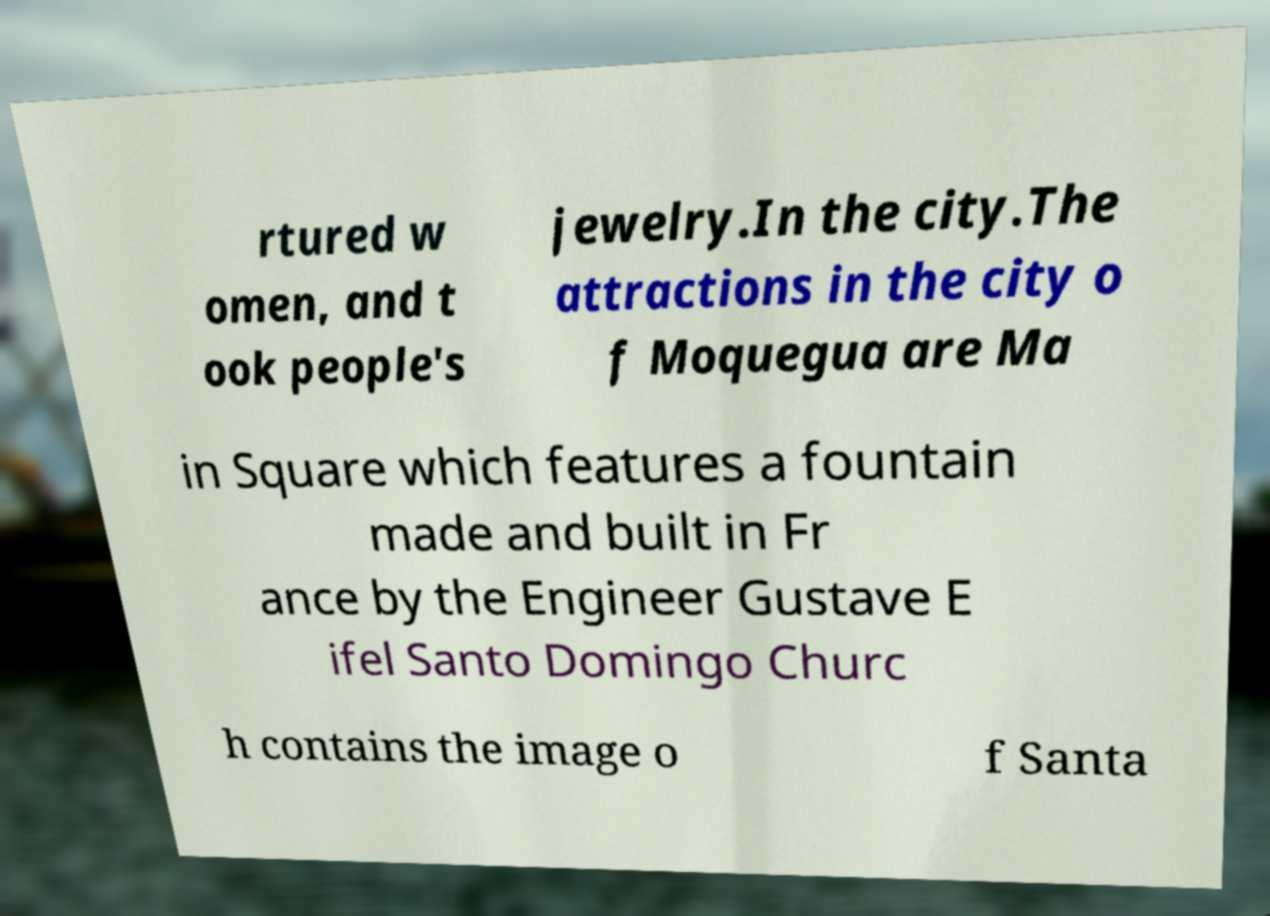Please read and relay the text visible in this image. What does it say? rtured w omen, and t ook people's jewelry.In the city.The attractions in the city o f Moquegua are Ma in Square which features a fountain made and built in Fr ance by the Engineer Gustave E ifel Santo Domingo Churc h contains the image o f Santa 